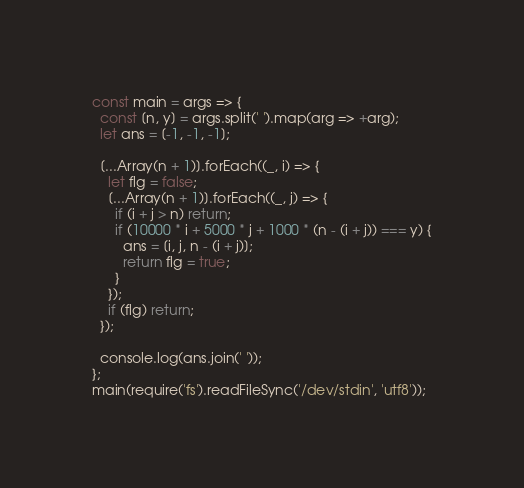<code> <loc_0><loc_0><loc_500><loc_500><_JavaScript_>const main = args => {
  const [n, y] = args.split(' ').map(arg => +arg);
  let ans = [-1, -1, -1];

  [...Array(n + 1)].forEach((_, i) => {
    let flg = false;
    [...Array(n + 1)].forEach((_, j) => {
      if (i + j > n) return;
      if (10000 * i + 5000 * j + 1000 * (n - (i + j)) === y) {
        ans = [i, j, n - (i + j)];
        return flg = true;
      }
    });
    if (flg) return;
  });

  console.log(ans.join(' '));
};
main(require('fs').readFileSync('/dev/stdin', 'utf8'));</code> 